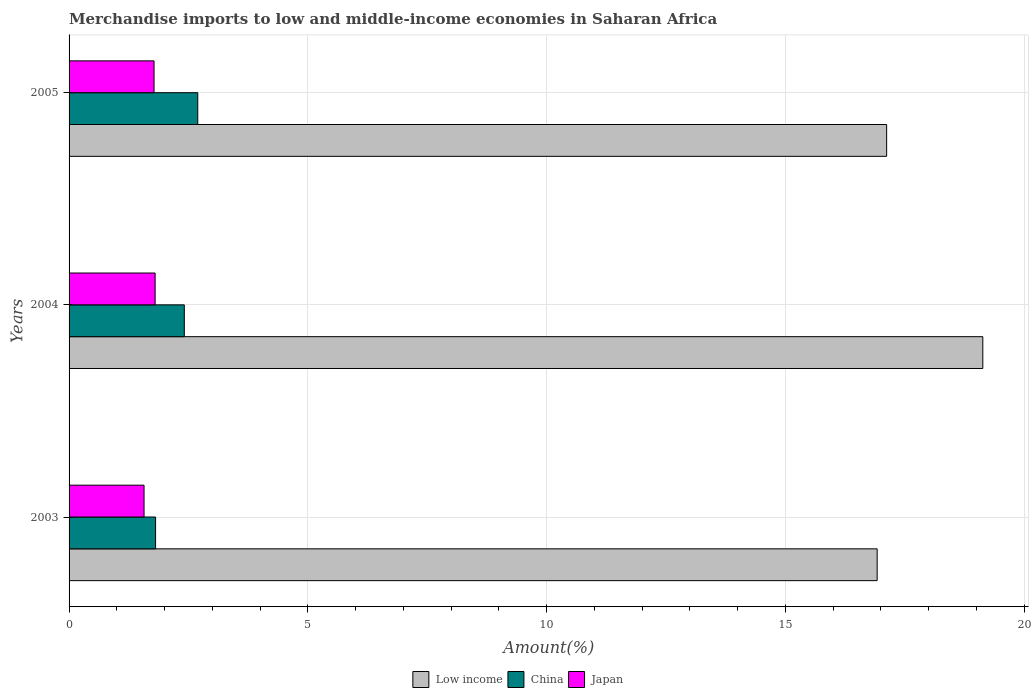How many groups of bars are there?
Ensure brevity in your answer.  3. Are the number of bars on each tick of the Y-axis equal?
Your answer should be very brief. Yes. In how many cases, is the number of bars for a given year not equal to the number of legend labels?
Make the answer very short. 0. What is the percentage of amount earned from merchandise imports in Low income in 2004?
Your answer should be compact. 19.13. Across all years, what is the maximum percentage of amount earned from merchandise imports in China?
Ensure brevity in your answer.  2.69. Across all years, what is the minimum percentage of amount earned from merchandise imports in Japan?
Your answer should be very brief. 1.57. In which year was the percentage of amount earned from merchandise imports in Low income maximum?
Provide a succinct answer. 2004. In which year was the percentage of amount earned from merchandise imports in China minimum?
Keep it short and to the point. 2003. What is the total percentage of amount earned from merchandise imports in China in the graph?
Your response must be concise. 6.92. What is the difference between the percentage of amount earned from merchandise imports in Japan in 2004 and that in 2005?
Give a very brief answer. 0.02. What is the difference between the percentage of amount earned from merchandise imports in Low income in 2004 and the percentage of amount earned from merchandise imports in China in 2003?
Your answer should be very brief. 17.32. What is the average percentage of amount earned from merchandise imports in Low income per year?
Offer a very short reply. 17.72. In the year 2004, what is the difference between the percentage of amount earned from merchandise imports in Japan and percentage of amount earned from merchandise imports in China?
Ensure brevity in your answer.  -0.61. What is the ratio of the percentage of amount earned from merchandise imports in Japan in 2004 to that in 2005?
Provide a succinct answer. 1.01. Is the difference between the percentage of amount earned from merchandise imports in Japan in 2003 and 2004 greater than the difference between the percentage of amount earned from merchandise imports in China in 2003 and 2004?
Your answer should be very brief. Yes. What is the difference between the highest and the second highest percentage of amount earned from merchandise imports in Low income?
Ensure brevity in your answer.  2.01. What is the difference between the highest and the lowest percentage of amount earned from merchandise imports in Japan?
Keep it short and to the point. 0.23. What does the 3rd bar from the bottom in 2004 represents?
Offer a terse response. Japan. How many bars are there?
Keep it short and to the point. 9. Are all the bars in the graph horizontal?
Offer a terse response. Yes. How many years are there in the graph?
Your response must be concise. 3. What is the difference between two consecutive major ticks on the X-axis?
Your answer should be compact. 5. Does the graph contain grids?
Make the answer very short. Yes. Where does the legend appear in the graph?
Provide a short and direct response. Bottom center. How many legend labels are there?
Your answer should be very brief. 3. How are the legend labels stacked?
Your answer should be compact. Horizontal. What is the title of the graph?
Ensure brevity in your answer.  Merchandise imports to low and middle-income economies in Saharan Africa. What is the label or title of the X-axis?
Ensure brevity in your answer.  Amount(%). What is the label or title of the Y-axis?
Offer a very short reply. Years. What is the Amount(%) of Low income in 2003?
Offer a very short reply. 16.92. What is the Amount(%) of China in 2003?
Provide a short and direct response. 1.81. What is the Amount(%) in Japan in 2003?
Offer a terse response. 1.57. What is the Amount(%) in Low income in 2004?
Keep it short and to the point. 19.13. What is the Amount(%) in China in 2004?
Your response must be concise. 2.41. What is the Amount(%) in Japan in 2004?
Offer a terse response. 1.8. What is the Amount(%) in Low income in 2005?
Offer a terse response. 17.12. What is the Amount(%) of China in 2005?
Offer a terse response. 2.69. What is the Amount(%) of Japan in 2005?
Ensure brevity in your answer.  1.78. Across all years, what is the maximum Amount(%) of Low income?
Provide a succinct answer. 19.13. Across all years, what is the maximum Amount(%) of China?
Your response must be concise. 2.69. Across all years, what is the maximum Amount(%) of Japan?
Provide a short and direct response. 1.8. Across all years, what is the minimum Amount(%) in Low income?
Ensure brevity in your answer.  16.92. Across all years, what is the minimum Amount(%) in China?
Give a very brief answer. 1.81. Across all years, what is the minimum Amount(%) of Japan?
Provide a short and direct response. 1.57. What is the total Amount(%) of Low income in the graph?
Your answer should be very brief. 53.17. What is the total Amount(%) in China in the graph?
Give a very brief answer. 6.92. What is the total Amount(%) of Japan in the graph?
Offer a very short reply. 5.15. What is the difference between the Amount(%) of Low income in 2003 and that in 2004?
Your answer should be very brief. -2.21. What is the difference between the Amount(%) of China in 2003 and that in 2004?
Make the answer very short. -0.6. What is the difference between the Amount(%) of Japan in 2003 and that in 2004?
Make the answer very short. -0.23. What is the difference between the Amount(%) of Low income in 2003 and that in 2005?
Your answer should be very brief. -0.2. What is the difference between the Amount(%) in China in 2003 and that in 2005?
Provide a succinct answer. -0.88. What is the difference between the Amount(%) in Japan in 2003 and that in 2005?
Your answer should be compact. -0.21. What is the difference between the Amount(%) in Low income in 2004 and that in 2005?
Offer a very short reply. 2.01. What is the difference between the Amount(%) in China in 2004 and that in 2005?
Offer a very short reply. -0.28. What is the difference between the Amount(%) in Japan in 2004 and that in 2005?
Your answer should be compact. 0.02. What is the difference between the Amount(%) of Low income in 2003 and the Amount(%) of China in 2004?
Give a very brief answer. 14.51. What is the difference between the Amount(%) of Low income in 2003 and the Amount(%) of Japan in 2004?
Your response must be concise. 15.12. What is the difference between the Amount(%) of China in 2003 and the Amount(%) of Japan in 2004?
Your answer should be compact. 0.01. What is the difference between the Amount(%) in Low income in 2003 and the Amount(%) in China in 2005?
Ensure brevity in your answer.  14.23. What is the difference between the Amount(%) of Low income in 2003 and the Amount(%) of Japan in 2005?
Keep it short and to the point. 15.14. What is the difference between the Amount(%) of China in 2003 and the Amount(%) of Japan in 2005?
Give a very brief answer. 0.03. What is the difference between the Amount(%) of Low income in 2004 and the Amount(%) of China in 2005?
Your answer should be compact. 16.44. What is the difference between the Amount(%) of Low income in 2004 and the Amount(%) of Japan in 2005?
Your response must be concise. 17.35. What is the difference between the Amount(%) of China in 2004 and the Amount(%) of Japan in 2005?
Make the answer very short. 0.63. What is the average Amount(%) in Low income per year?
Give a very brief answer. 17.72. What is the average Amount(%) in China per year?
Ensure brevity in your answer.  2.31. What is the average Amount(%) of Japan per year?
Your answer should be compact. 1.72. In the year 2003, what is the difference between the Amount(%) in Low income and Amount(%) in China?
Give a very brief answer. 15.11. In the year 2003, what is the difference between the Amount(%) of Low income and Amount(%) of Japan?
Provide a short and direct response. 15.35. In the year 2003, what is the difference between the Amount(%) in China and Amount(%) in Japan?
Your response must be concise. 0.24. In the year 2004, what is the difference between the Amount(%) of Low income and Amount(%) of China?
Give a very brief answer. 16.72. In the year 2004, what is the difference between the Amount(%) in Low income and Amount(%) in Japan?
Keep it short and to the point. 17.33. In the year 2004, what is the difference between the Amount(%) in China and Amount(%) in Japan?
Give a very brief answer. 0.61. In the year 2005, what is the difference between the Amount(%) of Low income and Amount(%) of China?
Provide a succinct answer. 14.42. In the year 2005, what is the difference between the Amount(%) in Low income and Amount(%) in Japan?
Your response must be concise. 15.34. In the year 2005, what is the difference between the Amount(%) in China and Amount(%) in Japan?
Keep it short and to the point. 0.92. What is the ratio of the Amount(%) of Low income in 2003 to that in 2004?
Provide a short and direct response. 0.88. What is the ratio of the Amount(%) in China in 2003 to that in 2004?
Your response must be concise. 0.75. What is the ratio of the Amount(%) of Japan in 2003 to that in 2004?
Your response must be concise. 0.87. What is the ratio of the Amount(%) of Low income in 2003 to that in 2005?
Your response must be concise. 0.99. What is the ratio of the Amount(%) of China in 2003 to that in 2005?
Provide a short and direct response. 0.67. What is the ratio of the Amount(%) of Japan in 2003 to that in 2005?
Your answer should be compact. 0.88. What is the ratio of the Amount(%) in Low income in 2004 to that in 2005?
Your answer should be very brief. 1.12. What is the ratio of the Amount(%) of China in 2004 to that in 2005?
Provide a short and direct response. 0.9. What is the ratio of the Amount(%) in Japan in 2004 to that in 2005?
Your answer should be compact. 1.01. What is the difference between the highest and the second highest Amount(%) of Low income?
Make the answer very short. 2.01. What is the difference between the highest and the second highest Amount(%) of China?
Provide a short and direct response. 0.28. What is the difference between the highest and the second highest Amount(%) in Japan?
Ensure brevity in your answer.  0.02. What is the difference between the highest and the lowest Amount(%) of Low income?
Your answer should be very brief. 2.21. What is the difference between the highest and the lowest Amount(%) of China?
Provide a succinct answer. 0.88. What is the difference between the highest and the lowest Amount(%) of Japan?
Provide a short and direct response. 0.23. 